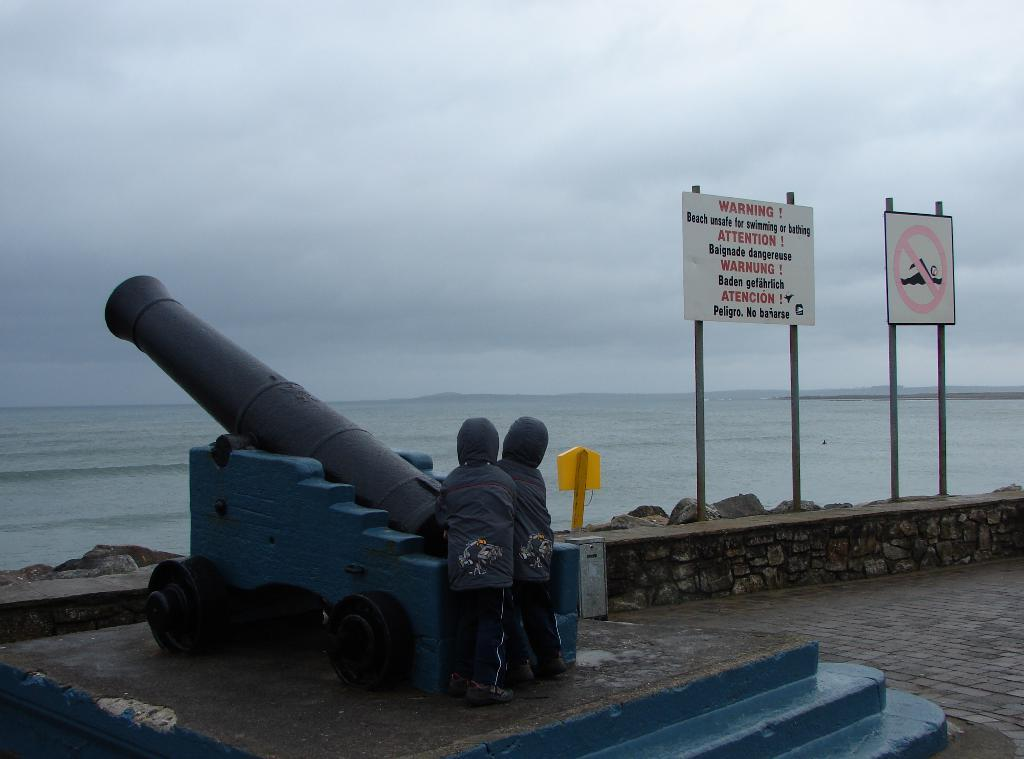What type of military weapon is in the image? There is a military weapon in the image, but the specific type cannot be determined from the provided facts. Who else is present in the image besides the military weapon? There are kids in the image. What other objects can be seen in the image? There are signboards, a rock wall, and poles in the image. What is visible in the background of the image? The background of the image includes the sky and water. How would you describe the weather based on the image? The sky is cloudy, which suggests a partly cloudy or overcast day. How many waves can be seen crashing against the rock wall in the image? There are no waves present in the image; it features a rock wall and water, but no waves can be seen. What type of fingerprint can be seen on the military weapon in the image? There is no fingerprint visible on the military weapon in the image. 